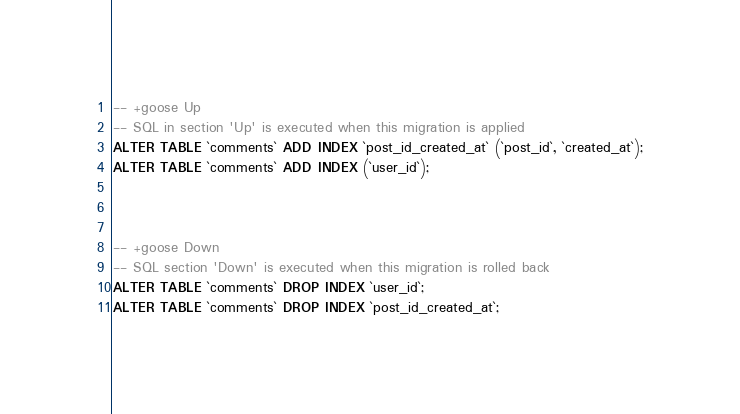Convert code to text. <code><loc_0><loc_0><loc_500><loc_500><_SQL_>
-- +goose Up
-- SQL in section 'Up' is executed when this migration is applied
ALTER TABLE `comments` ADD INDEX `post_id_created_at` (`post_id`, `created_at`);
ALTER TABLE `comments` ADD INDEX (`user_id`);



-- +goose Down
-- SQL section 'Down' is executed when this migration is rolled back
ALTER TABLE `comments` DROP INDEX `user_id`;
ALTER TABLE `comments` DROP INDEX `post_id_created_at`;

</code> 